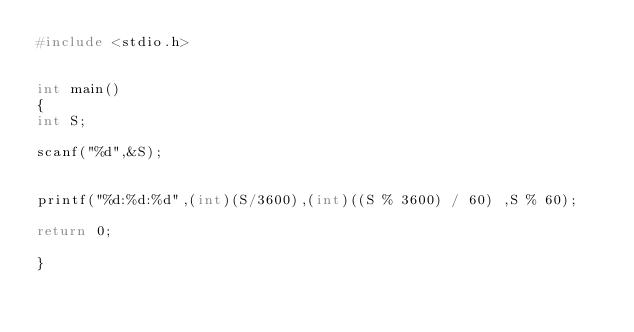<code> <loc_0><loc_0><loc_500><loc_500><_C_>#include <stdio.h>


int main()
{
int S;

scanf("%d",&S);


printf("%d:%d:%d",(int)(S/3600),(int)((S % 3600) / 60) ,S % 60);

return 0;

}</code> 